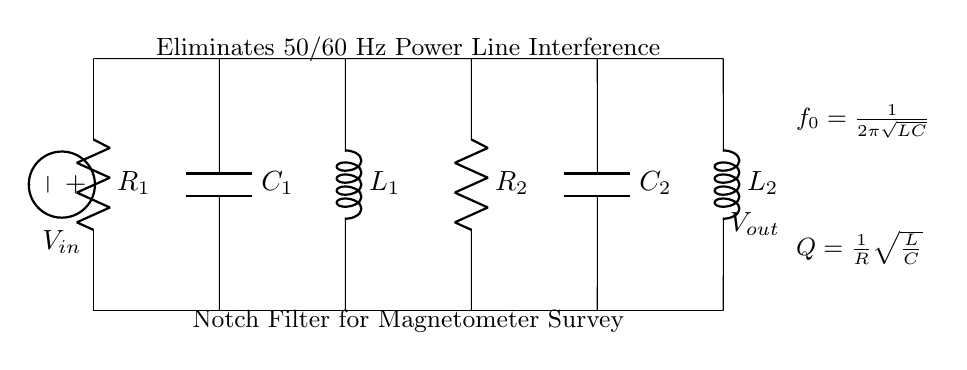What type of filter is represented in the circuit? The circuit represents a notch filter, which is specifically designed to eliminate a narrow band of frequencies, particularly for removing power line interference.
Answer: notch filter What are the reactive components in the circuit? The reactive components include the inductor and capacitors, which are essential in creating the desired frequency response for filtering.
Answer: inductor and capacitors What frequency does the circuit target for elimination? The circuit is aimed at eliminating 50/60 Hz frequencies, which are typical power line interference frequencies.
Answer: 50/60 Hz What does the formula \(f_0 = \frac{1}{2\pi\sqrt{LC}}\) represent in the context of this filter? This formula calculates the resonant frequency \(f_0\) of the filter based on the values of the inductance \(L\) and capacitance \(C\), indicating the frequency at which the filter most effectively rejects signals.
Answer: resonant frequency How does increasing the resistance value \(R\) affect the quality factor \(Q\) of the notch filter? Increasing the resistance \(R\) decreases the quality factor \(Q\), leading to wider bandwidth and less selectivity in filtering, as \(Q\) is inversely proportional to \(R\).
Answer: decreases \(Q\) What is the voltage source represented as \(V_{in}\) in the circuit? The voltage source \(V_{in}\) is the input signal to the circuit, which may contain interference that the filter aims to eliminate.
Answer: input signal What is the purpose of \(R_2\) in the circuit? \(R_2\) may serve as a part of a load resistance or provide damping in the circuit, influencing the filter's overall performance and stability.
Answer: damping resistor 